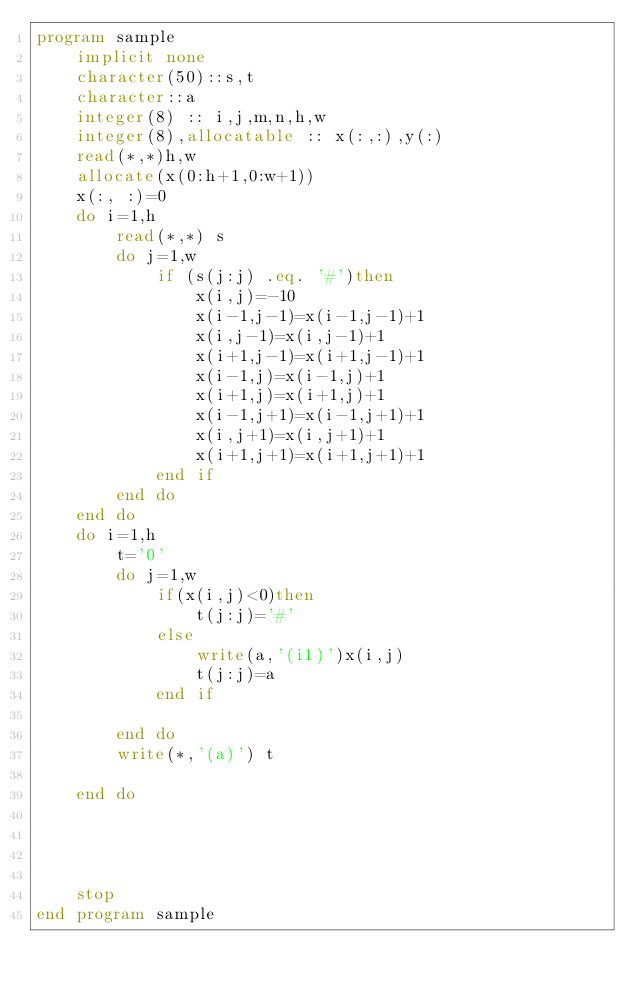<code> <loc_0><loc_0><loc_500><loc_500><_FORTRAN_>program sample
    implicit none
    character(50)::s,t
    character::a
    integer(8) :: i,j,m,n,h,w
    integer(8),allocatable :: x(:,:),y(:)
    read(*,*)h,w
    allocate(x(0:h+1,0:w+1))
    x(:, :)=0
    do i=1,h
        read(*,*) s
        do j=1,w
            if (s(j:j) .eq. '#')then
                x(i,j)=-10
                x(i-1,j-1)=x(i-1,j-1)+1
                x(i,j-1)=x(i,j-1)+1
                x(i+1,j-1)=x(i+1,j-1)+1
                x(i-1,j)=x(i-1,j)+1
                x(i+1,j)=x(i+1,j)+1
                x(i-1,j+1)=x(i-1,j+1)+1
                x(i,j+1)=x(i,j+1)+1
                x(i+1,j+1)=x(i+1,j+1)+1
            end if
        end do
    end do
    do i=1,h
        t='0'
        do j=1,w
            if(x(i,j)<0)then
                t(j:j)='#'
            else
                write(a,'(i1)')x(i,j)
                t(j:j)=a
            end if

        end do
        write(*,'(a)') t

    end do

    
   
  
    stop
end program sample
  

</code> 